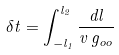Convert formula to latex. <formula><loc_0><loc_0><loc_500><loc_500>\delta t = \int _ { - l _ { 1 } } ^ { l _ { 2 } } \frac { d l } { v \, g _ { o o } }</formula> 